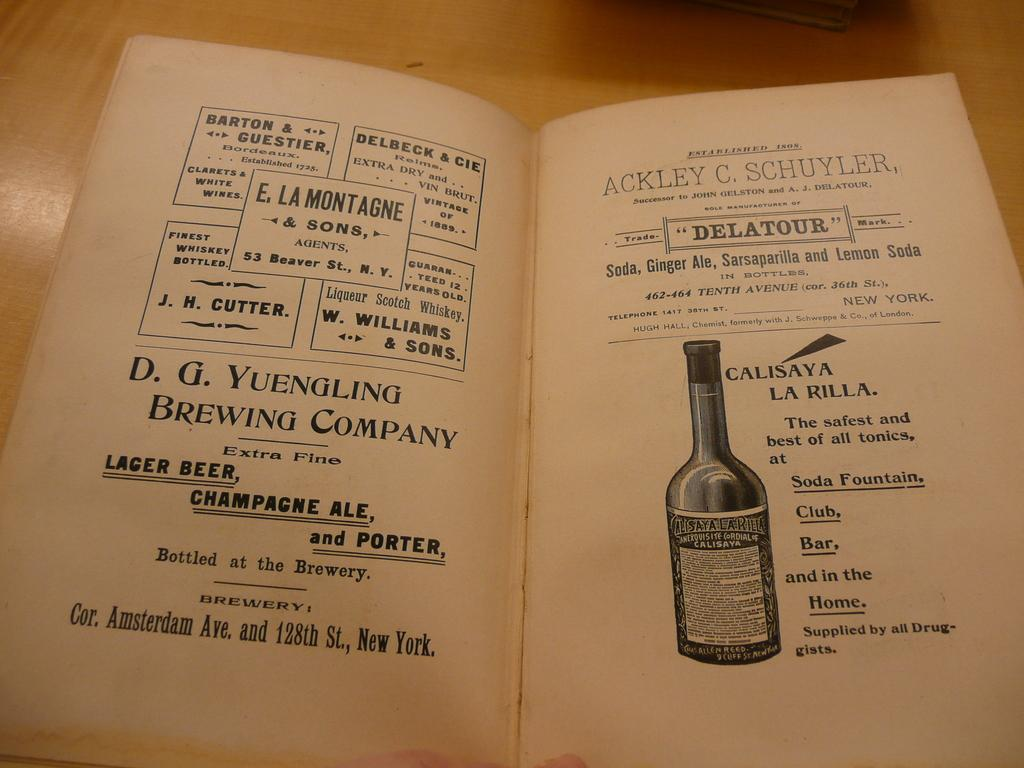Provide a one-sentence caption for the provided image. Pages from an old book about a lager beer  shows the bottle and details about it. 